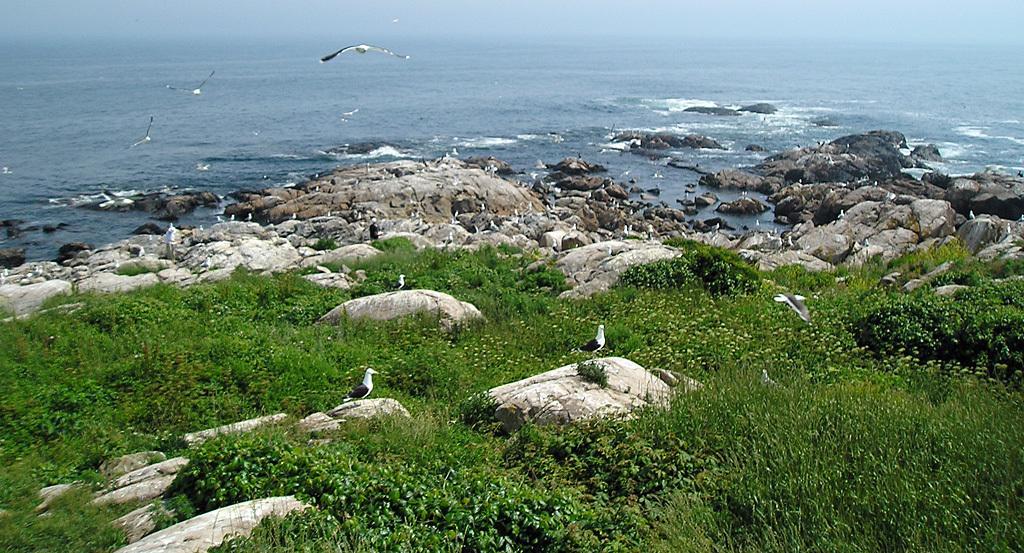In one or two sentences, can you explain what this image depicts? This image is taken outdoors. At the bottom of the image there is a ground with grass and rocks on it. At the top of the image there is a sea. In the middle of the image a few birds are flying in the air and there are many birds on the rocks. 